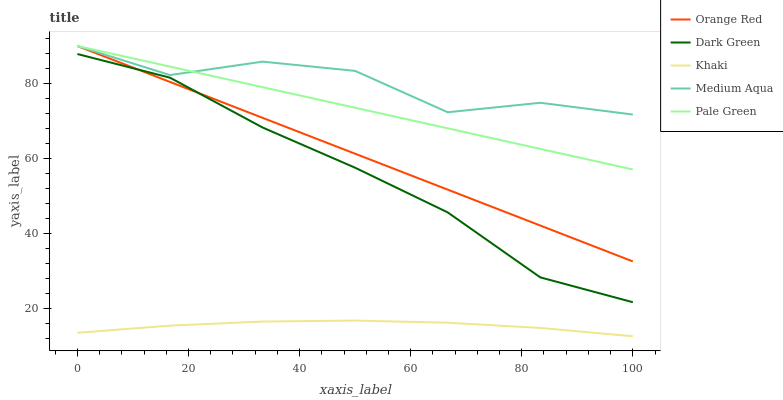Does Khaki have the minimum area under the curve?
Answer yes or no. Yes. Does Medium Aqua have the maximum area under the curve?
Answer yes or no. Yes. Does Medium Aqua have the minimum area under the curve?
Answer yes or no. No. Does Khaki have the maximum area under the curve?
Answer yes or no. No. Is Orange Red the smoothest?
Answer yes or no. Yes. Is Medium Aqua the roughest?
Answer yes or no. Yes. Is Khaki the smoothest?
Answer yes or no. No. Is Khaki the roughest?
Answer yes or no. No. Does Khaki have the lowest value?
Answer yes or no. Yes. Does Medium Aqua have the lowest value?
Answer yes or no. No. Does Orange Red have the highest value?
Answer yes or no. Yes. Does Khaki have the highest value?
Answer yes or no. No. Is Khaki less than Pale Green?
Answer yes or no. Yes. Is Medium Aqua greater than Dark Green?
Answer yes or no. Yes. Does Dark Green intersect Orange Red?
Answer yes or no. Yes. Is Dark Green less than Orange Red?
Answer yes or no. No. Is Dark Green greater than Orange Red?
Answer yes or no. No. Does Khaki intersect Pale Green?
Answer yes or no. No. 